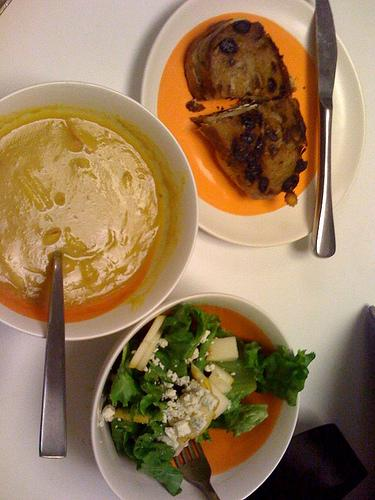What are some of the ingredients found in the apple feta and lettuce salad? The ingredients in the salad include lettuce, blue cheese, and pieces of tofu. Count the number of plates, bowls, and silverware in the image. There are 3 plates, 4 bowls, and 3 pieces of silverware in the image. In what position is the fork placed within the image? The fork is placed in a small white bowl with some salad, and its handle is sticking out. What type of sentiment could be associated with this image? A positive sentiment could be associated with the image, as it showcases a delicious and well-presented meal. What kind of silverware can you find in the image? There is a knife, a fork, and a spoon in the image. Describe the appearance of the knife in the image. The knife is silver with a long handle, and it lies on the edge of the plate with a light glare on the handle. Please provide a short description of the different types of food on the table. There is an apple feta and lettuce salad, orange soup in a white bowl, brown bread with raisins, tofu, and a lightly baked steak on the table. Identify the types of bowls in the image and describe their contents. There are two white bowls: one oval with orange sauce and salad inside, and one round with orange soup inside. What kind of table is shown in the image? The image shows a white table with multiple dishes, bowls, and silverware on it. Detect three objects related to the orange soup and describe their features. There is an orange and white salad bowl, a spoon in the soup bowl, and orange sauce on a white plate. Can you see a glass of wine in the image? No, it's not mentioned in the image. What adjective best describes the fork in the image? Used Based on the image, write a story about a dinner party. Once upon a time, a classy dinner party showcased a delicious array of dishes, from the vibrant bowl of simmering orange soup to a tantalizing salad with apples, feta, and blue cheese. The table was dressed in white, adorned with dark napkins and gleaming utensils to celebrate the flavorsome feast. Finally, a plate of warm brown bread with raisins greeted the guests, marking the beginning of a gathering that would bring joy and satisfaction to all who attended. Using the events shown in the image, create a narrative of what is happening around the table. An enticing dinner is set upon the pristine white table, with the orange soup gracefully resting in the round bowl and a wholesome salad eagerly waiting in another. A supporting cast of utensils complete the delicious scene, hinting that the meal will soon be enjoyed. Identify the type of food in the white round bowl. Orange soup Please count the number of primary objects on the white table. 5 (2 white bowls, 1 plate, knife, and fork) Describe the type of bread displayed in the image. Brown bread with raisins Is there a green tablecloth covering the table? The table is described as white, and there is no mention of a tablecloth, especially not a green one. Which of the following utensils is present in the image: a) Spoon b) Fork c) Chopsticks? b) Fork Do you see a silver butterknife placed on the side of a plate? Yes Write a haiku inspired by the dinner elements in the image. Orange soup simmers, What color is the napkin placed next to the salad bowl? Dark Choose the correct description of the dish from the following: a) An exquisite seafood platter b) A scrumptious vegetarian feast c) A rich and hearty stew b) A scrumptious vegetarian feast What is the shape of the white bowl with orange inside and salad? Oval What are the main ingredients seen in the salad? Lettuce, apple, feta and blue cheese Write a brief description of the knife handle's appearance. There's light glare on the silver knife handle What utensils can be seen in the image? Knife, fork, and spoon Where is the fork placed in the image? In the small white bowl Provide a stylish caption for the soup bowl. A delectable orange symphony awaiting to tantalize the taste buds State one of the side dishes on the white table. Apple, feta, and lettuce salad 